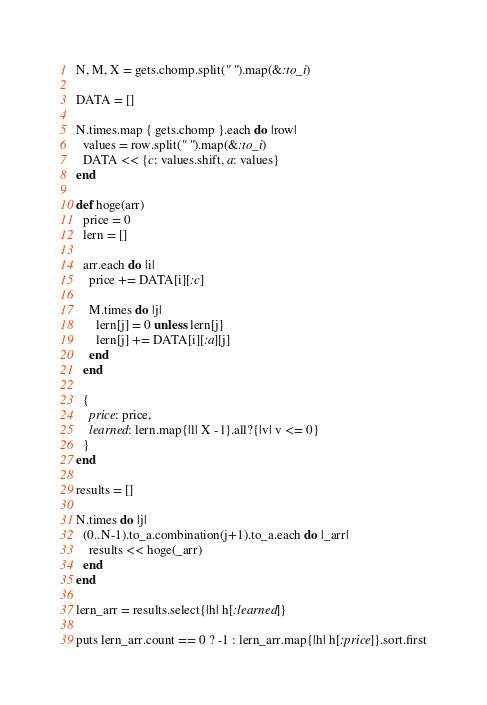Convert code to text. <code><loc_0><loc_0><loc_500><loc_500><_Ruby_>N, M, X = gets.chomp.split(" ").map(&:to_i)

DATA = []

N.times.map { gets.chomp }.each do |row|
  values = row.split(" ").map(&:to_i)
  DATA << {c: values.shift, a: values}
end

def hoge(arr)
  price = 0
  lern = []

  arr.each do |i|
    price += DATA[i][:c]

    M.times do |j|
      lern[j] = 0 unless lern[j]
      lern[j] += DATA[i][:a][j]
    end
  end

  {
    price: price,
    learned: lern.map{|l| X - l}.all?{|v| v <= 0}
  }
end

results = []

N.times do |j|
  (0..N-1).to_a.combination(j+1).to_a.each do |_arr|
    results << hoge(_arr)
  end
end

lern_arr = results.select{|h| h[:learned]}

puts lern_arr.count == 0 ? -1 : lern_arr.map{|h| h[:price]}.sort.first</code> 